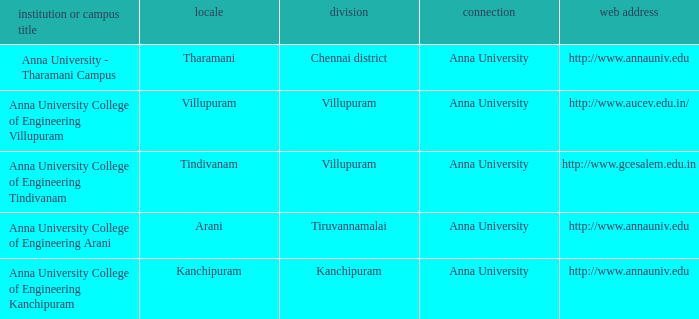What Weblink has a College or Campus Name of anna university college of engineering kanchipuram? Http://www.annauniv.edu. 